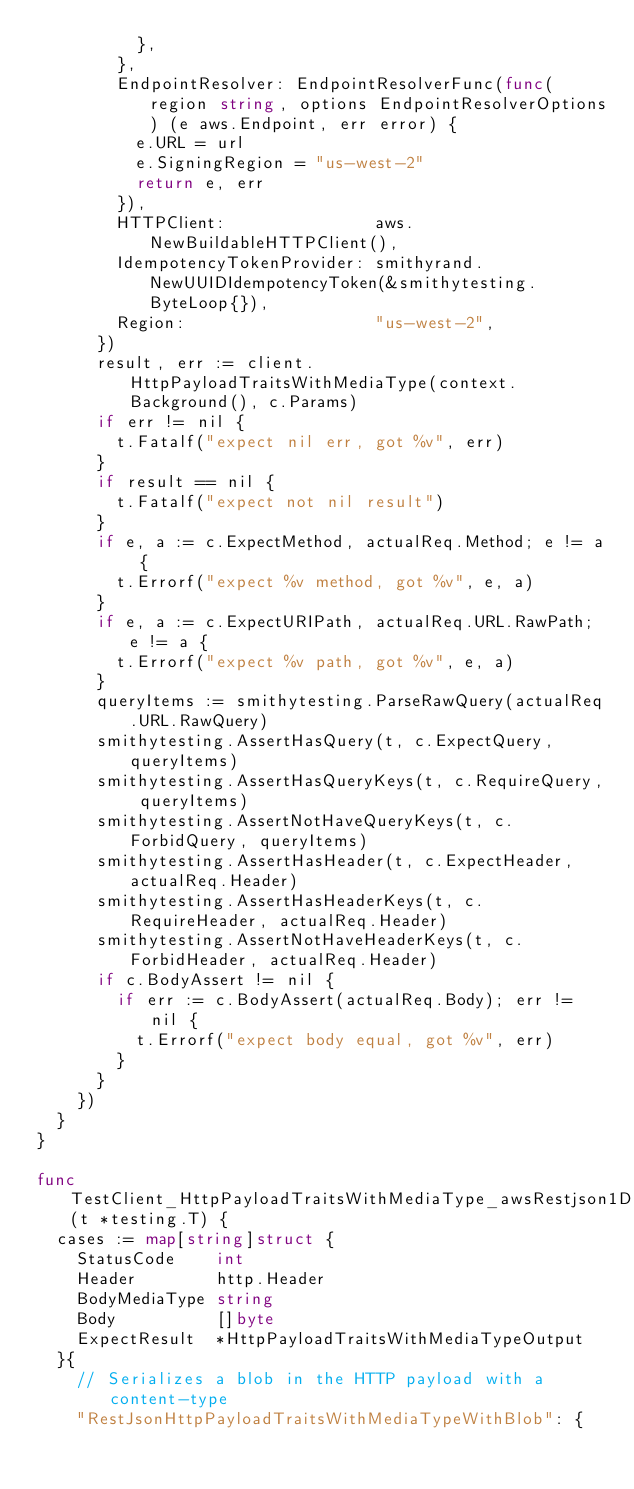Convert code to text. <code><loc_0><loc_0><loc_500><loc_500><_Go_>					},
				},
				EndpointResolver: EndpointResolverFunc(func(region string, options EndpointResolverOptions) (e aws.Endpoint, err error) {
					e.URL = url
					e.SigningRegion = "us-west-2"
					return e, err
				}),
				HTTPClient:               aws.NewBuildableHTTPClient(),
				IdempotencyTokenProvider: smithyrand.NewUUIDIdempotencyToken(&smithytesting.ByteLoop{}),
				Region:                   "us-west-2",
			})
			result, err := client.HttpPayloadTraitsWithMediaType(context.Background(), c.Params)
			if err != nil {
				t.Fatalf("expect nil err, got %v", err)
			}
			if result == nil {
				t.Fatalf("expect not nil result")
			}
			if e, a := c.ExpectMethod, actualReq.Method; e != a {
				t.Errorf("expect %v method, got %v", e, a)
			}
			if e, a := c.ExpectURIPath, actualReq.URL.RawPath; e != a {
				t.Errorf("expect %v path, got %v", e, a)
			}
			queryItems := smithytesting.ParseRawQuery(actualReq.URL.RawQuery)
			smithytesting.AssertHasQuery(t, c.ExpectQuery, queryItems)
			smithytesting.AssertHasQueryKeys(t, c.RequireQuery, queryItems)
			smithytesting.AssertNotHaveQueryKeys(t, c.ForbidQuery, queryItems)
			smithytesting.AssertHasHeader(t, c.ExpectHeader, actualReq.Header)
			smithytesting.AssertHasHeaderKeys(t, c.RequireHeader, actualReq.Header)
			smithytesting.AssertNotHaveHeaderKeys(t, c.ForbidHeader, actualReq.Header)
			if c.BodyAssert != nil {
				if err := c.BodyAssert(actualReq.Body); err != nil {
					t.Errorf("expect body equal, got %v", err)
				}
			}
		})
	}
}

func TestClient_HttpPayloadTraitsWithMediaType_awsRestjson1Deserialize(t *testing.T) {
	cases := map[string]struct {
		StatusCode    int
		Header        http.Header
		BodyMediaType string
		Body          []byte
		ExpectResult  *HttpPayloadTraitsWithMediaTypeOutput
	}{
		// Serializes a blob in the HTTP payload with a content-type
		"RestJsonHttpPayloadTraitsWithMediaTypeWithBlob": {</code> 